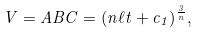<formula> <loc_0><loc_0><loc_500><loc_500>V = A B C = ( n \ell t + c _ { 1 } ) ^ { \frac { 3 } { n } } ,</formula> 